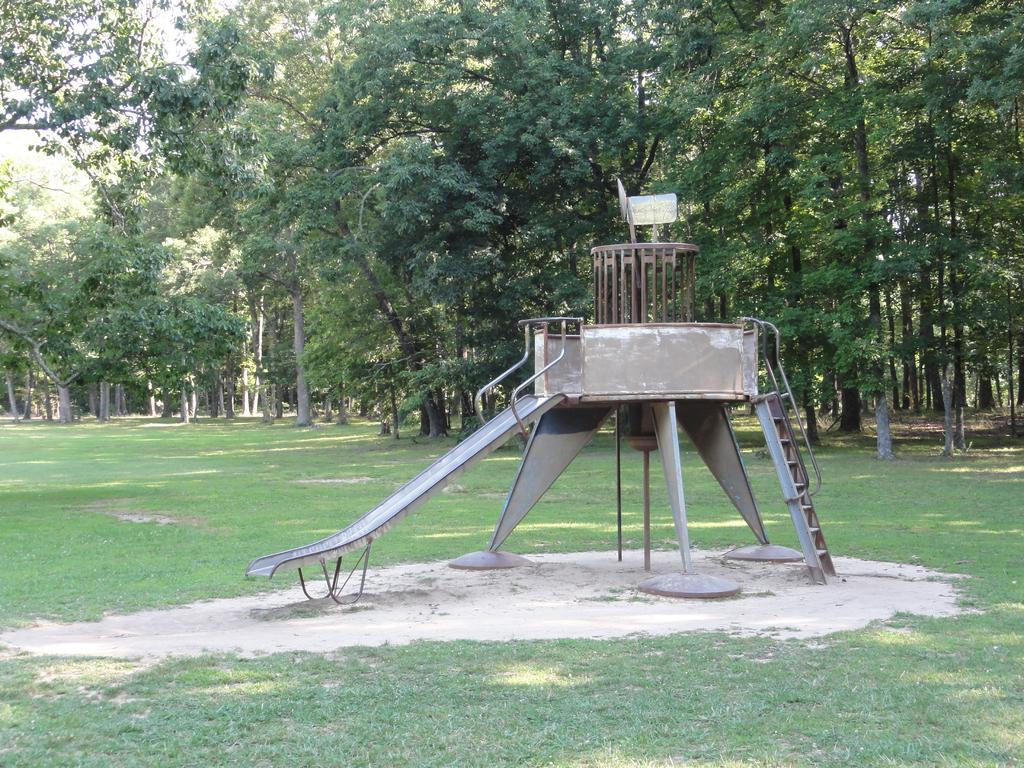What type of playground equipment is in the image? There is a slider in the image. What other equipment is present in the image? There is a ladder in the image. What is the ground surface like in the image? The grass is visible in the image. What else can be seen on the ground in the image? There are other objects on the ground in the image. What can be seen in the background of the image? There are trees and the sky visible in the background of the image. How many stars can be seen on the slider in the image? There are no stars present on the slider in the image. What type of balance is required to use the ladder in the image? The image does not show any specific balance requirements for using the ladder. 